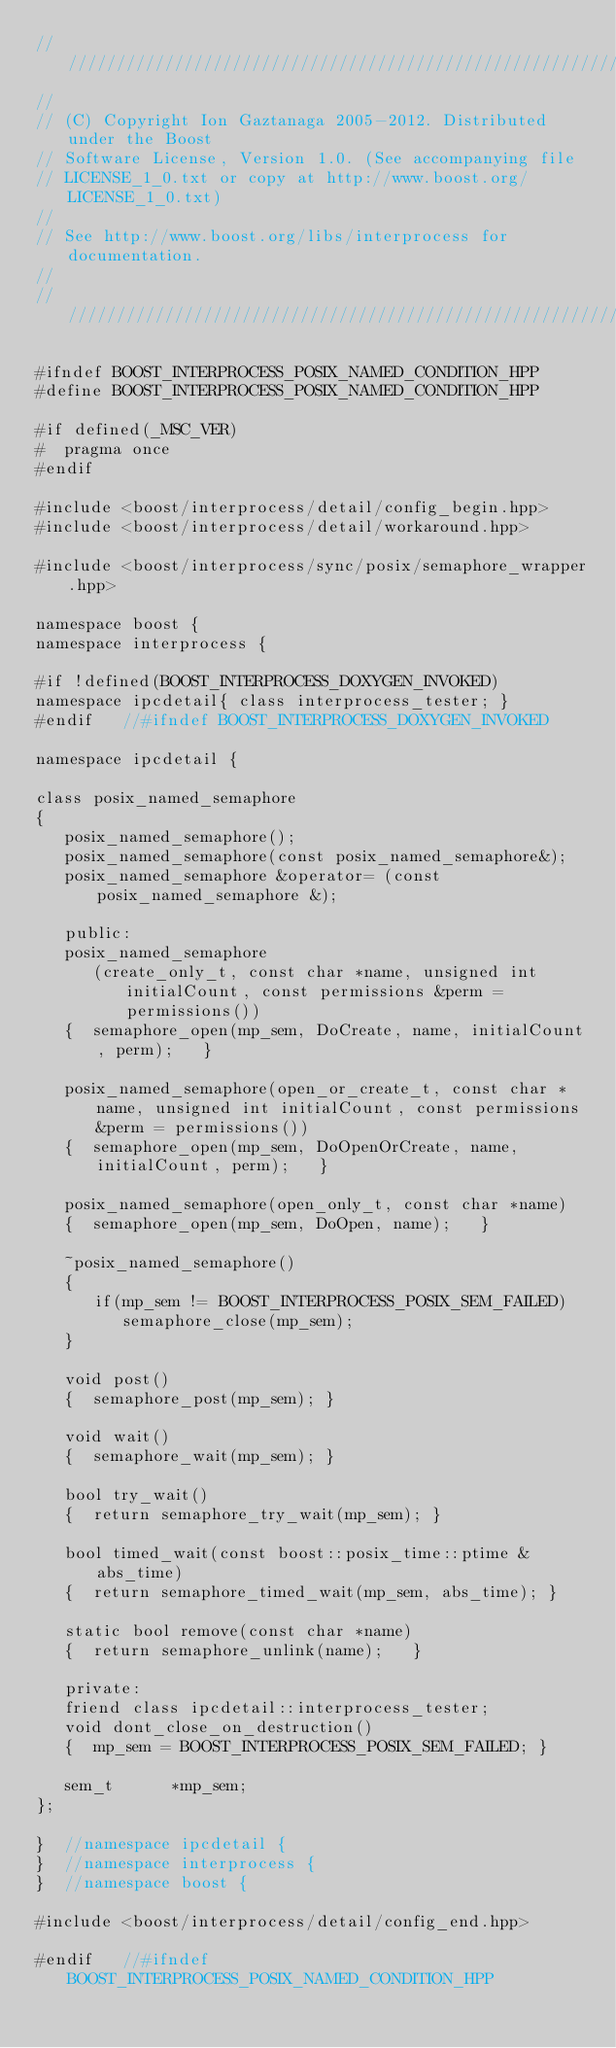<code> <loc_0><loc_0><loc_500><loc_500><_C++_>//////////////////////////////////////////////////////////////////////////////
//
// (C) Copyright Ion Gaztanaga 2005-2012. Distributed under the Boost
// Software License, Version 1.0. (See accompanying file
// LICENSE_1_0.txt or copy at http://www.boost.org/LICENSE_1_0.txt)
//
// See http://www.boost.org/libs/interprocess for documentation.
//
//////////////////////////////////////////////////////////////////////////////

#ifndef BOOST_INTERPROCESS_POSIX_NAMED_CONDITION_HPP
#define BOOST_INTERPROCESS_POSIX_NAMED_CONDITION_HPP

#if defined(_MSC_VER)
#  pragma once
#endif

#include <boost/interprocess/detail/config_begin.hpp>
#include <boost/interprocess/detail/workaround.hpp>

#include <boost/interprocess/sync/posix/semaphore_wrapper.hpp>

namespace boost {
namespace interprocess {

#if !defined(BOOST_INTERPROCESS_DOXYGEN_INVOKED)
namespace ipcdetail{ class interprocess_tester; }
#endif   //#ifndef BOOST_INTERPROCESS_DOXYGEN_INVOKED

namespace ipcdetail {

class posix_named_semaphore
{
   posix_named_semaphore();
   posix_named_semaphore(const posix_named_semaphore&);
   posix_named_semaphore &operator= (const posix_named_semaphore &);

   public:
   posix_named_semaphore
      (create_only_t, const char *name, unsigned int initialCount, const permissions &perm = permissions())
   {  semaphore_open(mp_sem, DoCreate, name, initialCount, perm);   }

   posix_named_semaphore(open_or_create_t, const char *name, unsigned int initialCount, const permissions &perm = permissions())
   {  semaphore_open(mp_sem, DoOpenOrCreate, name, initialCount, perm);   }

   posix_named_semaphore(open_only_t, const char *name)
   {  semaphore_open(mp_sem, DoOpen, name);   }

   ~posix_named_semaphore()
   {
      if(mp_sem != BOOST_INTERPROCESS_POSIX_SEM_FAILED)
         semaphore_close(mp_sem);
   }

   void post()
   {  semaphore_post(mp_sem); }

   void wait()
   {  semaphore_wait(mp_sem); }

   bool try_wait()
   {  return semaphore_try_wait(mp_sem); }

   bool timed_wait(const boost::posix_time::ptime &abs_time)
   {  return semaphore_timed_wait(mp_sem, abs_time); }

   static bool remove(const char *name)
   {  return semaphore_unlink(name);   }

   private:
   friend class ipcdetail::interprocess_tester;
   void dont_close_on_destruction()
   {  mp_sem = BOOST_INTERPROCESS_POSIX_SEM_FAILED; }

   sem_t      *mp_sem;
};

}  //namespace ipcdetail {
}  //namespace interprocess {
}  //namespace boost {

#include <boost/interprocess/detail/config_end.hpp>

#endif   //#ifndef BOOST_INTERPROCESS_POSIX_NAMED_CONDITION_HPP
</code> 